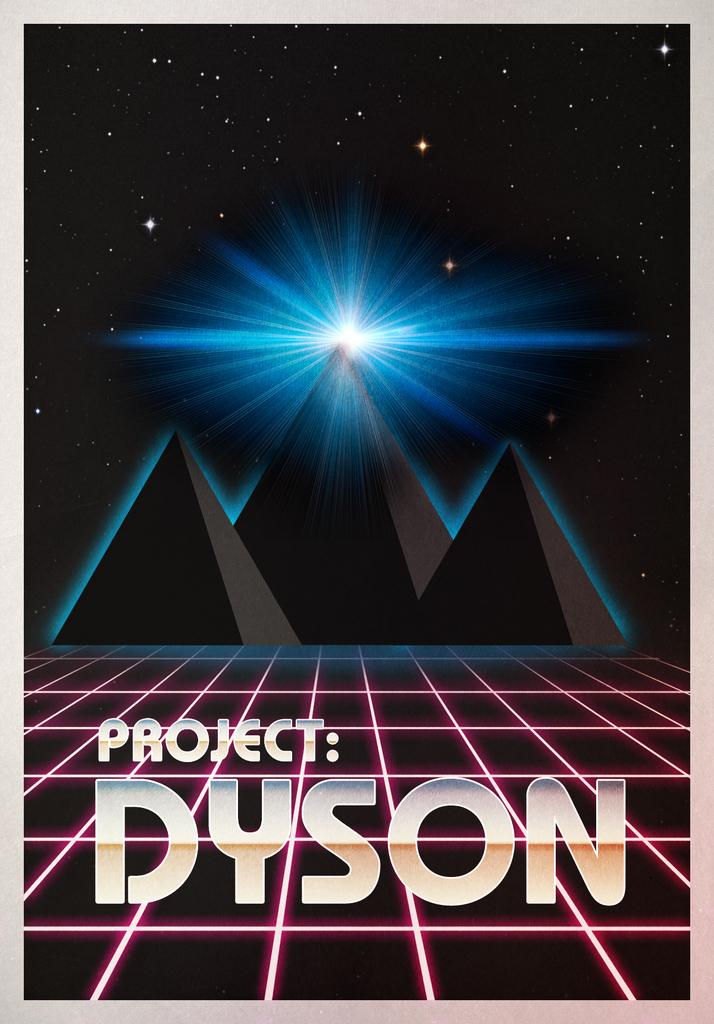<image>
Render a clear and concise summary of the photo. A poster for Project: Dyson showing an animated mountain range. 